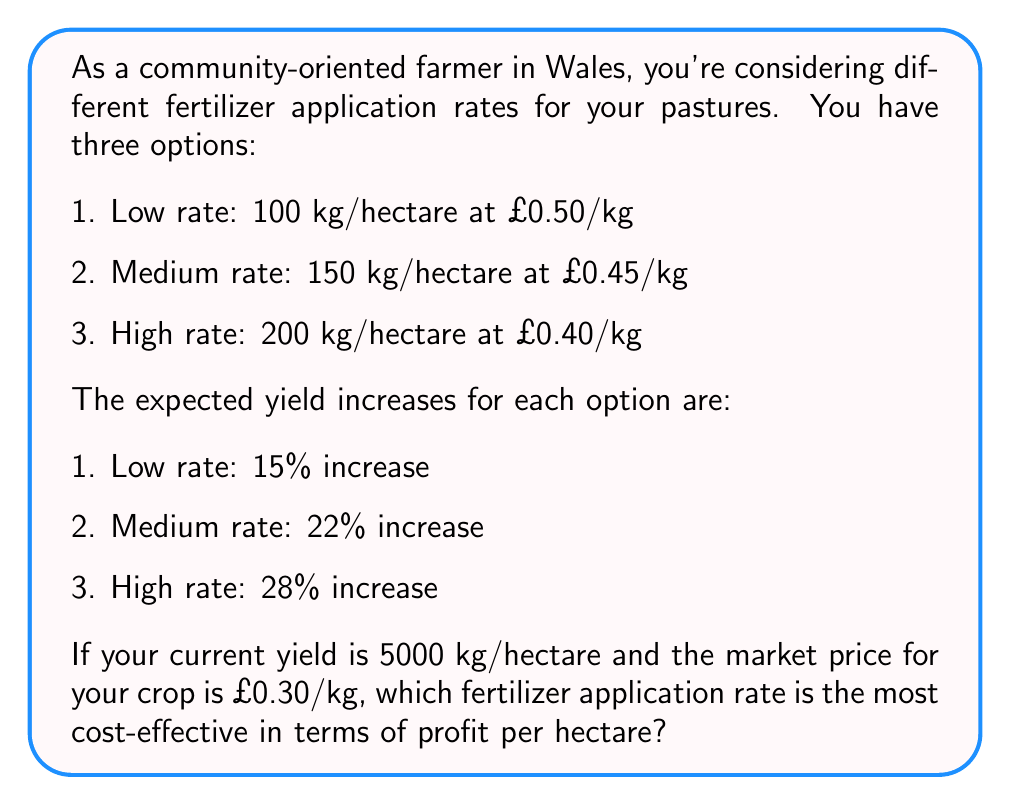Can you answer this question? To determine the most cost-effective fertilizer application rate, we need to calculate the profit for each option and compare them. Let's break it down step by step:

1. Calculate the cost of fertilizer per hectare for each option:
   - Low rate: $100 \text{ kg/ha} \times £0.50/\text{kg} = £50/\text{ha}$
   - Medium rate: $150 \text{ kg/ha} \times £0.45/\text{kg} = £67.50/\text{ha}$
   - High rate: $200 \text{ kg/ha} \times £0.40/\text{kg} = £80/\text{ha}$

2. Calculate the new yield for each option:
   - Low rate: $5000 \text{ kg/ha} \times 1.15 = 5750 \text{ kg/ha}$
   - Medium rate: $5000 \text{ kg/ha} \times 1.22 = 6100 \text{ kg/ha}$
   - High rate: $5000 \text{ kg/ha} \times 1.28 = 6400 \text{ kg/ha}$

3. Calculate the revenue for each option:
   - Low rate: $5750 \text{ kg/ha} \times £0.30/\text{kg} = £1725/\text{ha}$
   - Medium rate: $6100 \text{ kg/ha} \times £0.30/\text{kg} = £1830/\text{ha}$
   - High rate: $6400 \text{ kg/ha} \times £0.30/\text{kg} = £1920/\text{ha}$

4. Calculate the profit (revenue minus fertilizer cost) for each option:
   - Low rate: $£1725/\text{ha} - £50/\text{ha} = £1675/\text{ha}$
   - Medium rate: $£1830/\text{ha} - £67.50/\text{ha} = £1762.50/\text{ha}$
   - High rate: $£1920/\text{ha} - £80/\text{ha} = £1840/\text{ha}$

5. Compare the profits:
   The high rate option yields the highest profit per hectare at £1840/ha.

Therefore, the most cost-effective fertilizer application rate is the high rate option.
Answer: The high rate fertilizer application (200 kg/hectare at £0.40/kg) is the most cost-effective, yielding a profit of £1840 per hectare. 